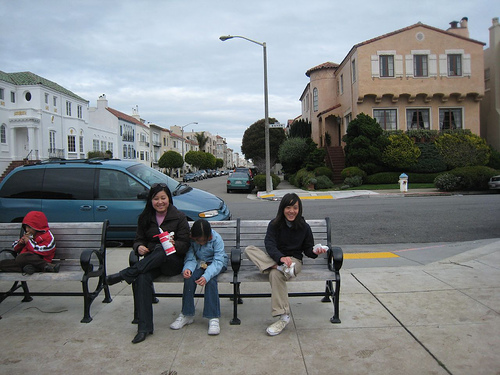How many people are there? There are four individuals in this image: a person on the left side partially obscured and seemingly engaged in a task that has them looking down, and three people seated on a bench to the right, casually enjoying each other's company with some beverages. The relaxed nature of the setting seems to suggest a pleasant, communal outdoor space, perhaps in a neighborhood with residential buildings lining the street in the background. 